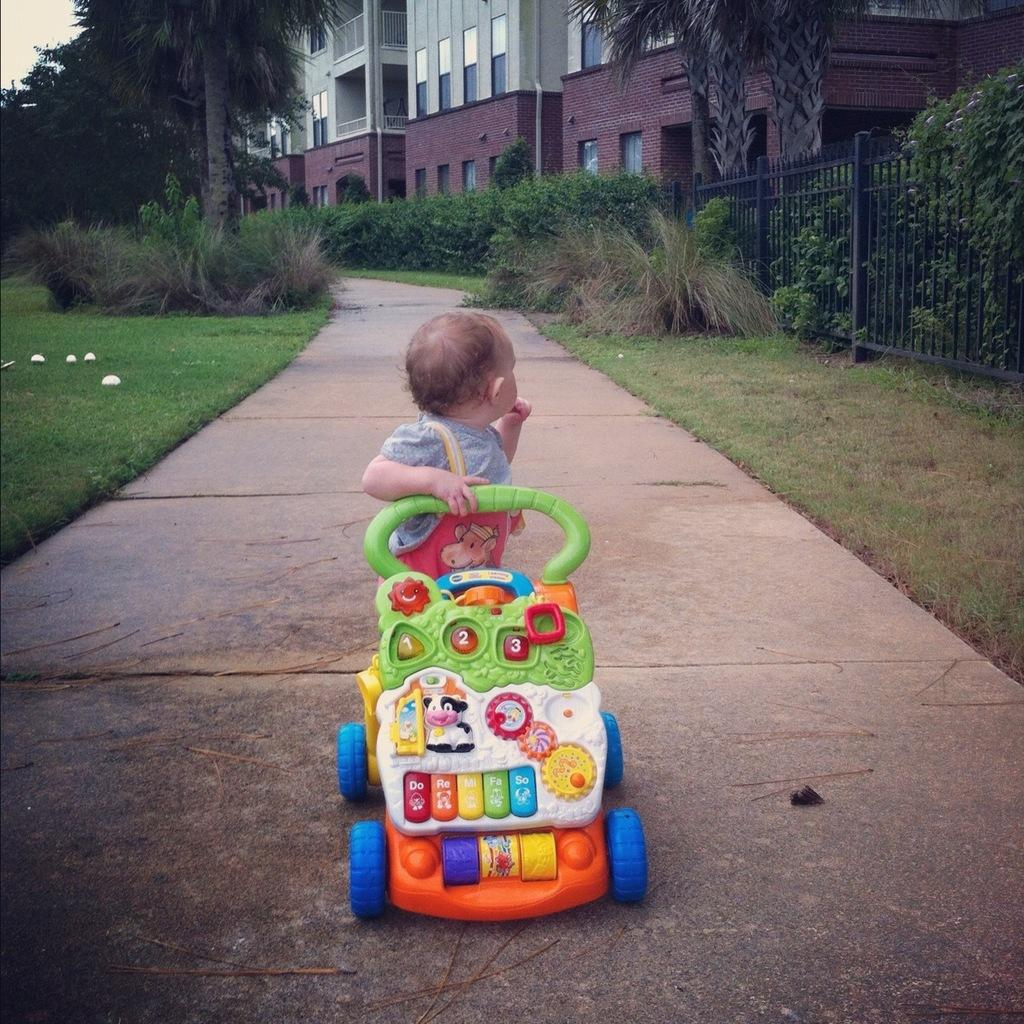What is the main subject of the image? A: There is a baby in a plastic car in the image. What type of terrain is visible on the left side of the image? There is grass on the ground at the left side of the image. What type of vegetation can be seen in the image? There are green color plants in the image. What type of natural structures are present in the image? There are trees in the image. What type of man-made structures are present in the image? There are buildings in the image. What type of juice is being served on the stage in the image? There is no stage or juice present in the image. What type of beast can be seen interacting with the baby in the plastic car? There is no beast present in the image; only the baby and the plastic car are visible. 